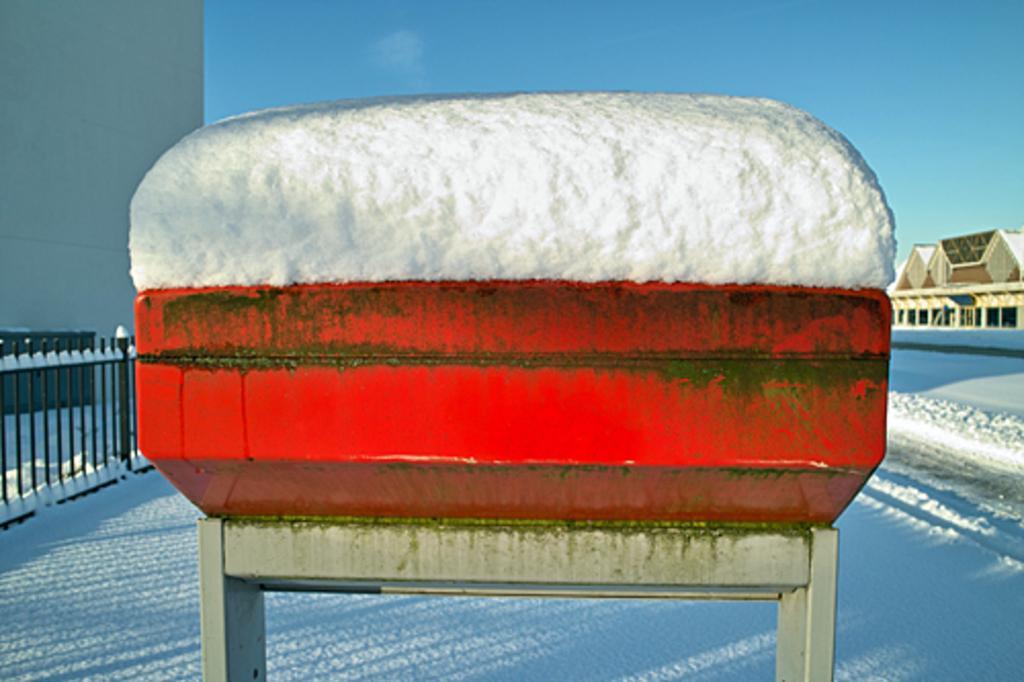Could you give a brief overview of what you see in this image? In this picture I can see a railing on the left side. In the middle it looks like a table, there is the snow. On the right side there are houses, at the top there is the sky. 